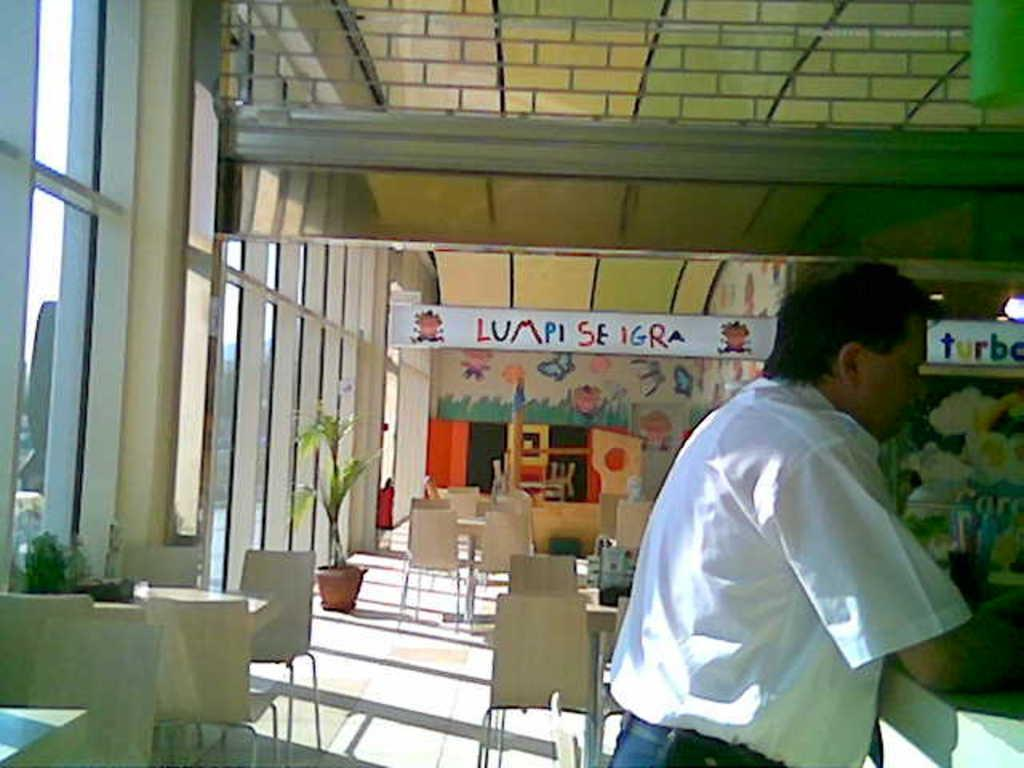What is the main subject in the image? There is a person standing in the image. What can be seen in the background of the image? There are tables, chairs, and lamps in the background of the image. What type of religion is being practiced in the image? There is no indication of any religious practice in the image. Can you see any icicles hanging from the lamps in the image? There are no icicles present in the image. 